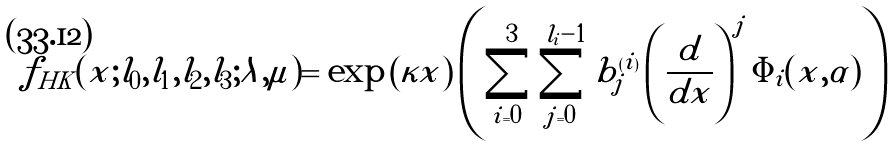<formula> <loc_0><loc_0><loc_500><loc_500>& f _ { H K } ( x ; l _ { 0 } , l _ { 1 } , l _ { 2 } , l _ { 3 } ; \lambda , \mu ) = \exp \left ( \kappa x \right ) \left ( \sum _ { i = 0 } ^ { 3 } \sum _ { j = 0 } ^ { \tilde { l } _ { i } - 1 } \tilde { b } ^ { ( i ) } _ { j } \left ( \frac { d } { d x } \right ) ^ { j } \Phi _ { i } ( x , \alpha ) \right )</formula> 